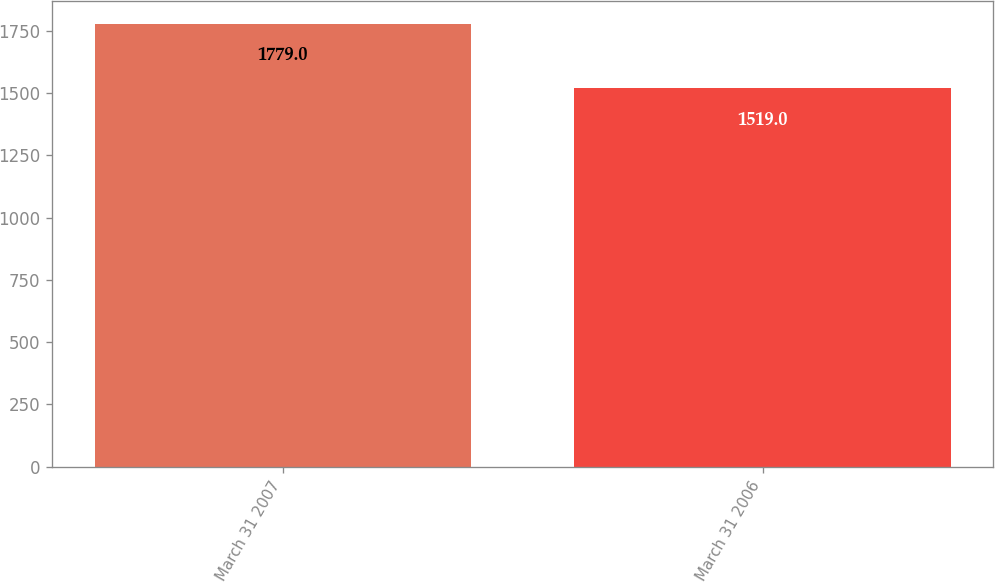<chart> <loc_0><loc_0><loc_500><loc_500><bar_chart><fcel>March 31 2007<fcel>March 31 2006<nl><fcel>1779<fcel>1519<nl></chart> 